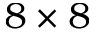<formula> <loc_0><loc_0><loc_500><loc_500>8 \times 8</formula> 